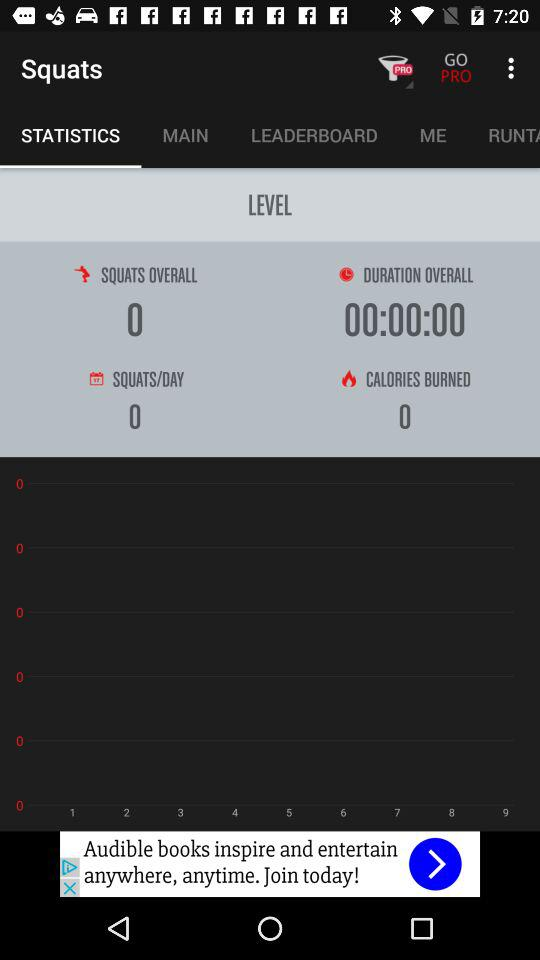How many calories have burned? There are zero calories burned. 